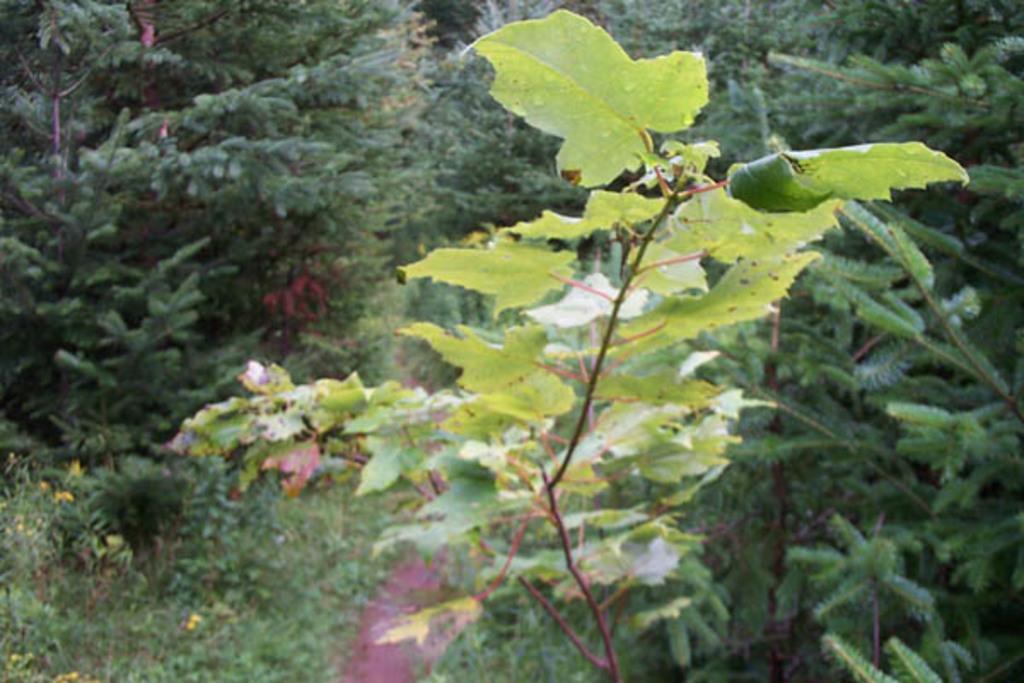How would you summarize this image in a sentence or two? A plant with medium size leaves. There is a path behind it. There are large number of plants and trees on either side of the path. 